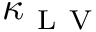<formula> <loc_0><loc_0><loc_500><loc_500>\kappa _ { L V }</formula> 